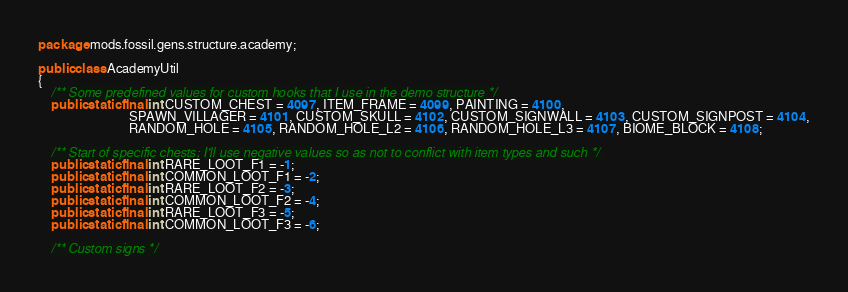Convert code to text. <code><loc_0><loc_0><loc_500><loc_500><_Java_>package mods.fossil.gens.structure.academy;

public class AcademyUtil
{
    /** Some predefined values for custom hooks that I use in the demo structure */
    public static final int CUSTOM_CHEST = 4097, ITEM_FRAME = 4099, PAINTING = 4100,
                            SPAWN_VILLAGER = 4101, CUSTOM_SKULL = 4102, CUSTOM_SIGNWALL = 4103, CUSTOM_SIGNPOST = 4104,
                            RANDOM_HOLE = 4105, RANDOM_HOLE_L2 = 4106, RANDOM_HOLE_L3 = 4107, BIOME_BLOCK = 4108;

    /** Start of specific chests; I'll use negative values so as not to conflict with item types and such */
    public static final int RARE_LOOT_F1 = -1;
    public static final int COMMON_LOOT_F1 = -2;
    public static final int RARE_LOOT_F2 = -3;
    public static final int COMMON_LOOT_F2 = -4;
    public static final int RARE_LOOT_F3 = -5;
    public static final int COMMON_LOOT_F3 = -6;

    /** Custom signs */</code> 